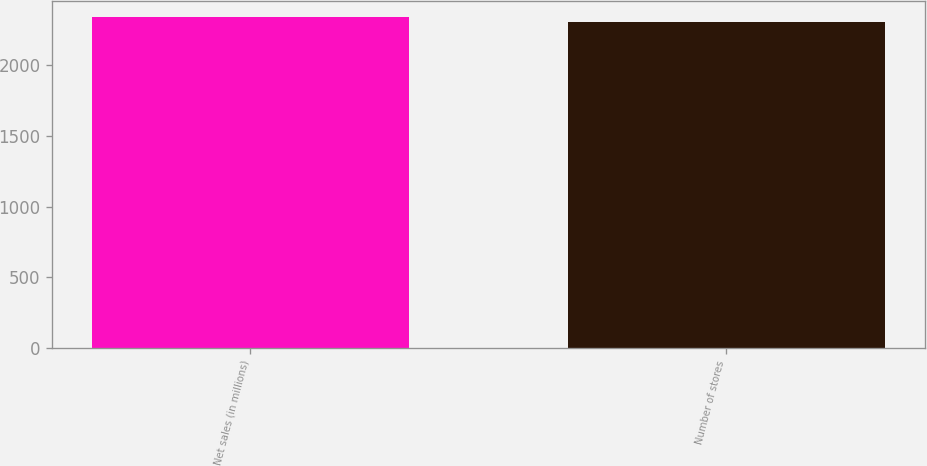Convert chart. <chart><loc_0><loc_0><loc_500><loc_500><bar_chart><fcel>Net sales (in millions)<fcel>Number of stores<nl><fcel>2340.4<fcel>2311<nl></chart> 